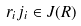<formula> <loc_0><loc_0><loc_500><loc_500>r _ { i } j _ { i } \in J ( R )</formula> 